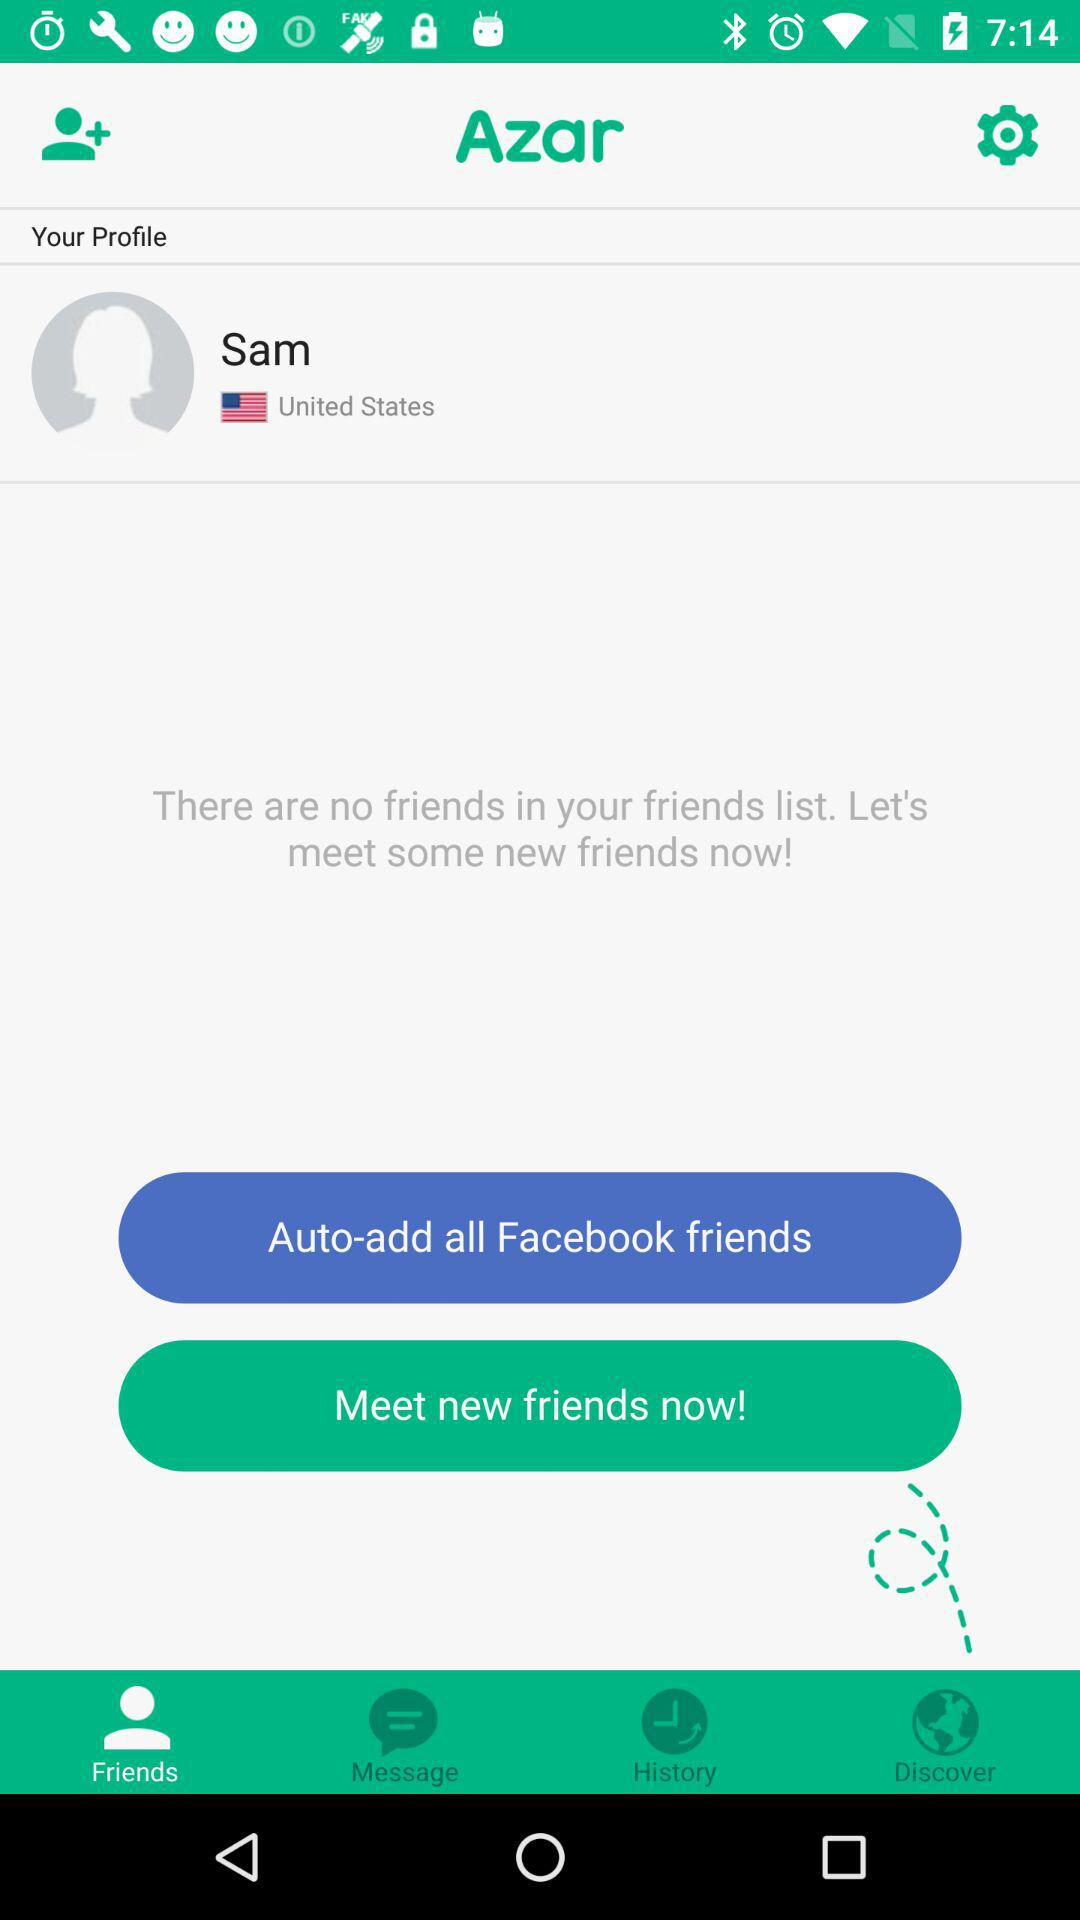Which tab has been selected? The selected tab is "Friends". 